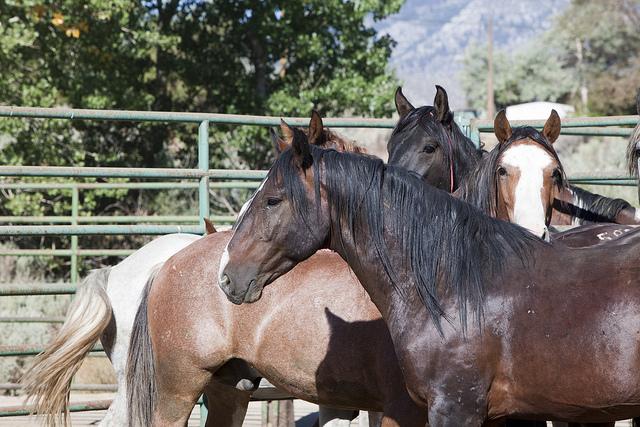How many of the horses have black manes?
Answer briefly. 3. What color is the gate behind the horses?
Give a very brief answer. Green. How many horses are pictured?
Quick response, please. 3. 